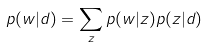Convert formula to latex. <formula><loc_0><loc_0><loc_500><loc_500>p ( w | d ) = \sum _ { z } p ( w | z ) p ( z | d )</formula> 